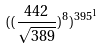<formula> <loc_0><loc_0><loc_500><loc_500>( ( \frac { 4 4 2 } { \sqrt { 3 8 9 } } ) ^ { 8 } ) ^ { 3 9 5 ^ { 1 } }</formula> 